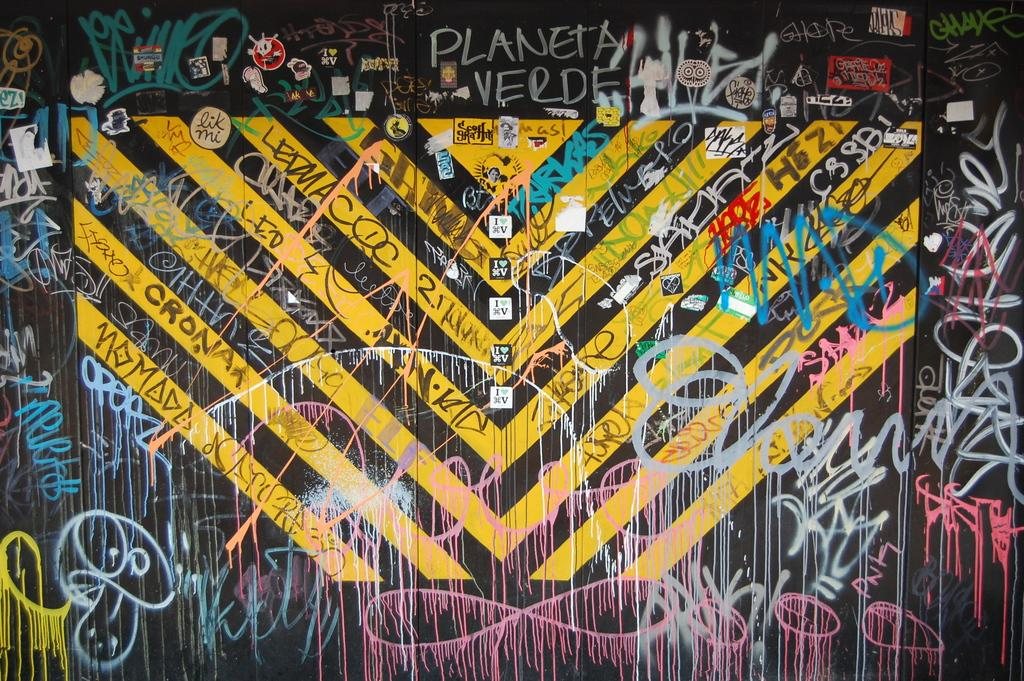<image>
Relay a brief, clear account of the picture shown. A bunch of grafiti on a wall on top saying Planeta verde. 